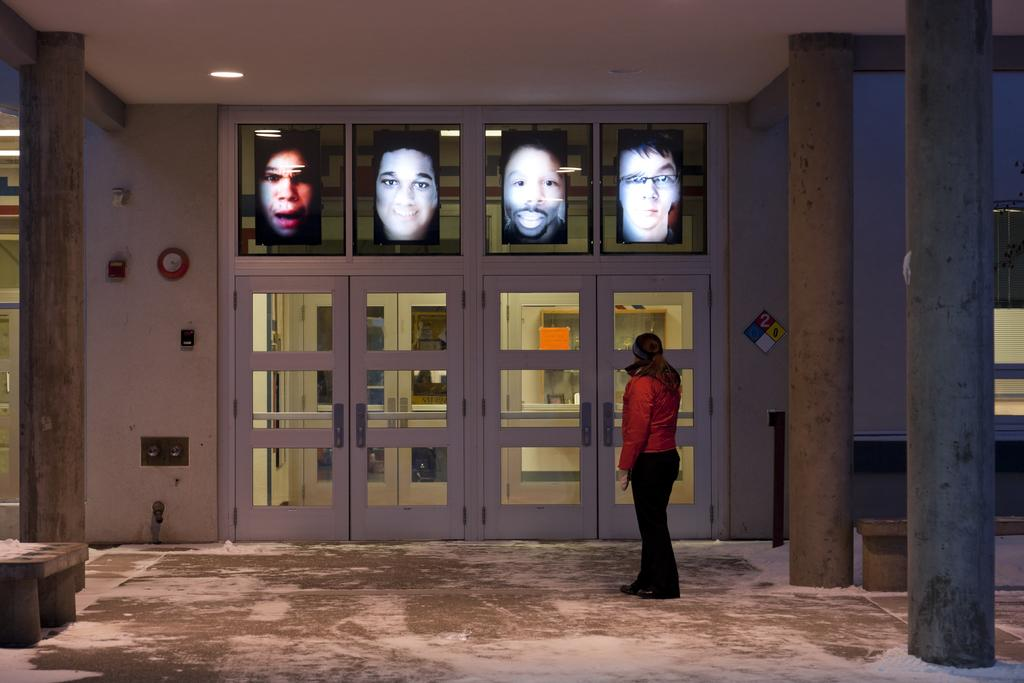What is the main subject in the foreground of the image? There is a person standing in the foreground of the image. What is the person standing on? The person is standing on the floor. What other objects are in the foreground of the image? There is a bench and pillars in the foreground of the image. What can be seen in the background of the image? There is a wall, windows, and photo frames in the background of the image. What type of location is depicted in the image? The image is taken in a hall. How many rabbits can be seen hopping around in the image? There are no rabbits present in the image. What type of mailbox is attached to the wall in the background? There is no mailbox present in the image. 